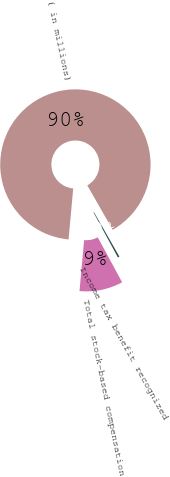Convert chart to OTSL. <chart><loc_0><loc_0><loc_500><loc_500><pie_chart><fcel>( in millions)<fcel>Total stock-based compensation<fcel>Income tax benefit recognized<nl><fcel>90.29%<fcel>9.35%<fcel>0.36%<nl></chart> 